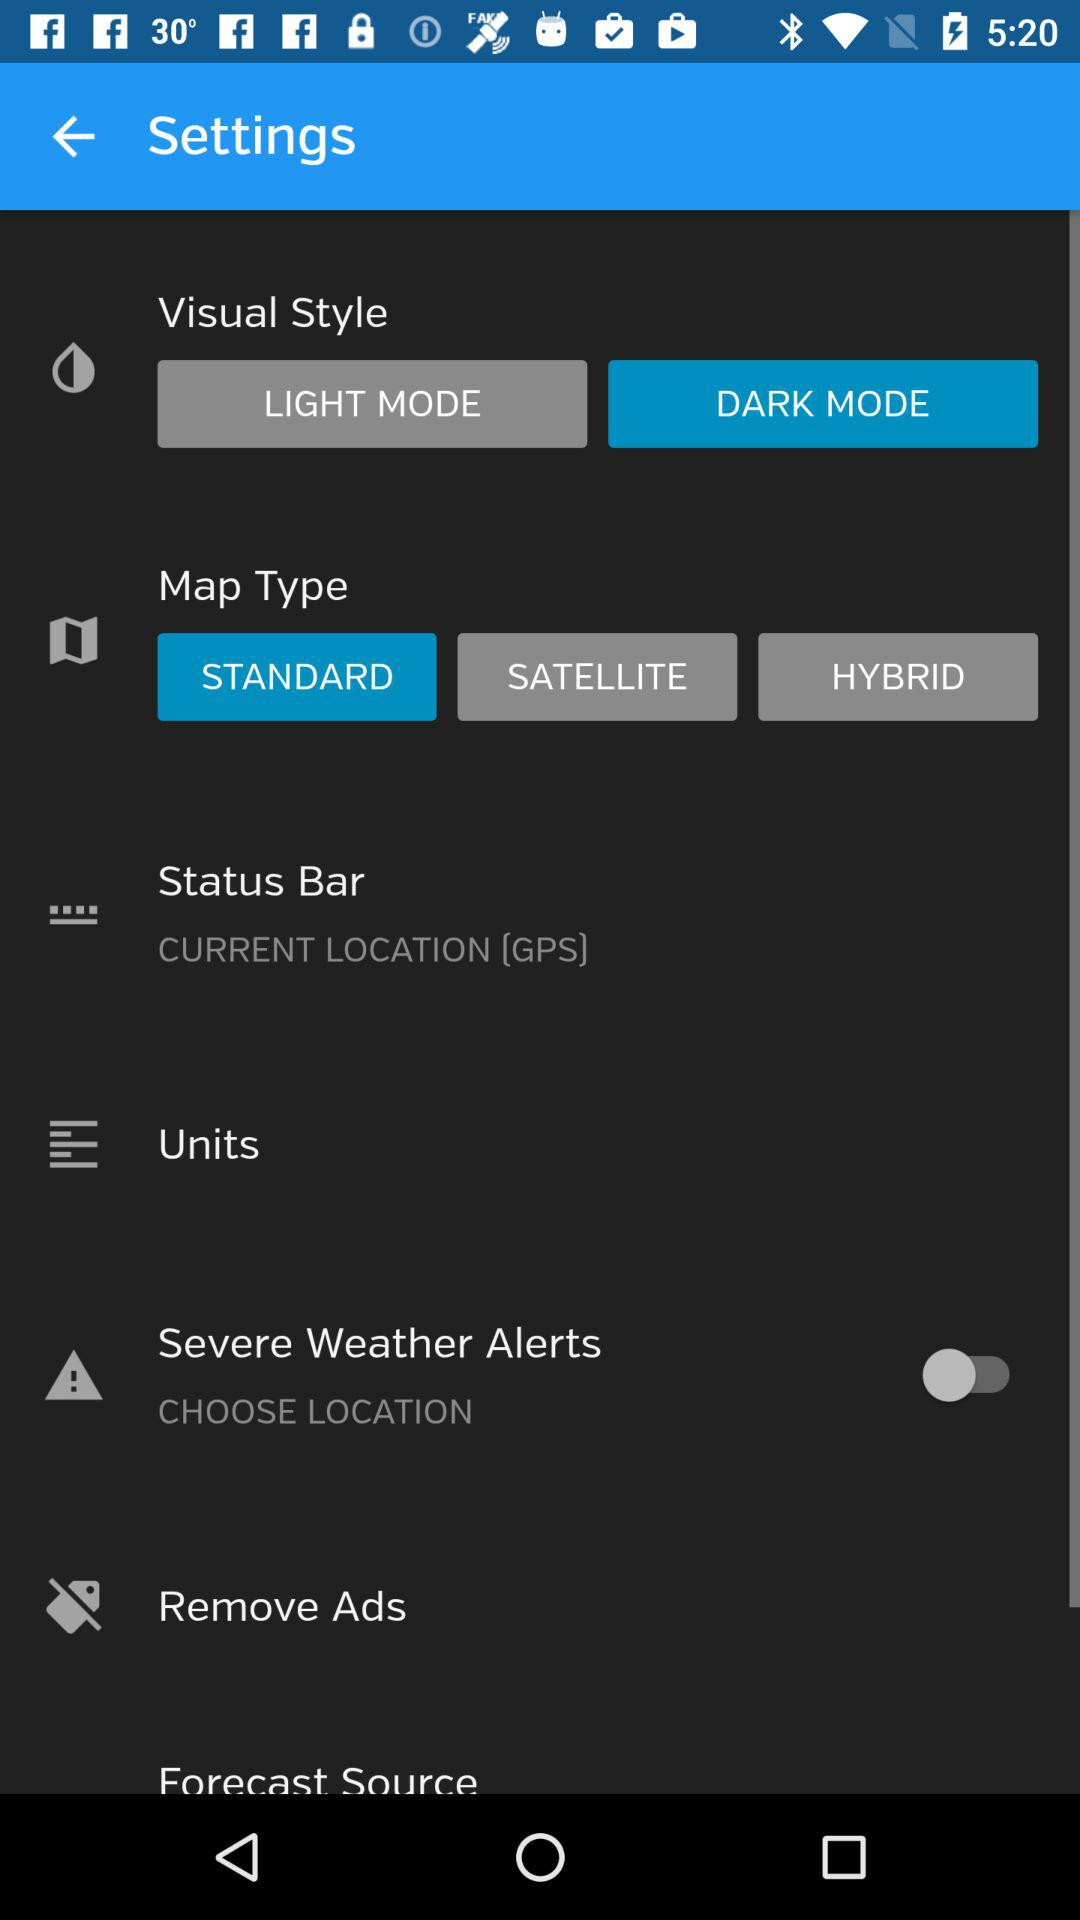Which map type has been selected? The selected map type is "STANDARD". 